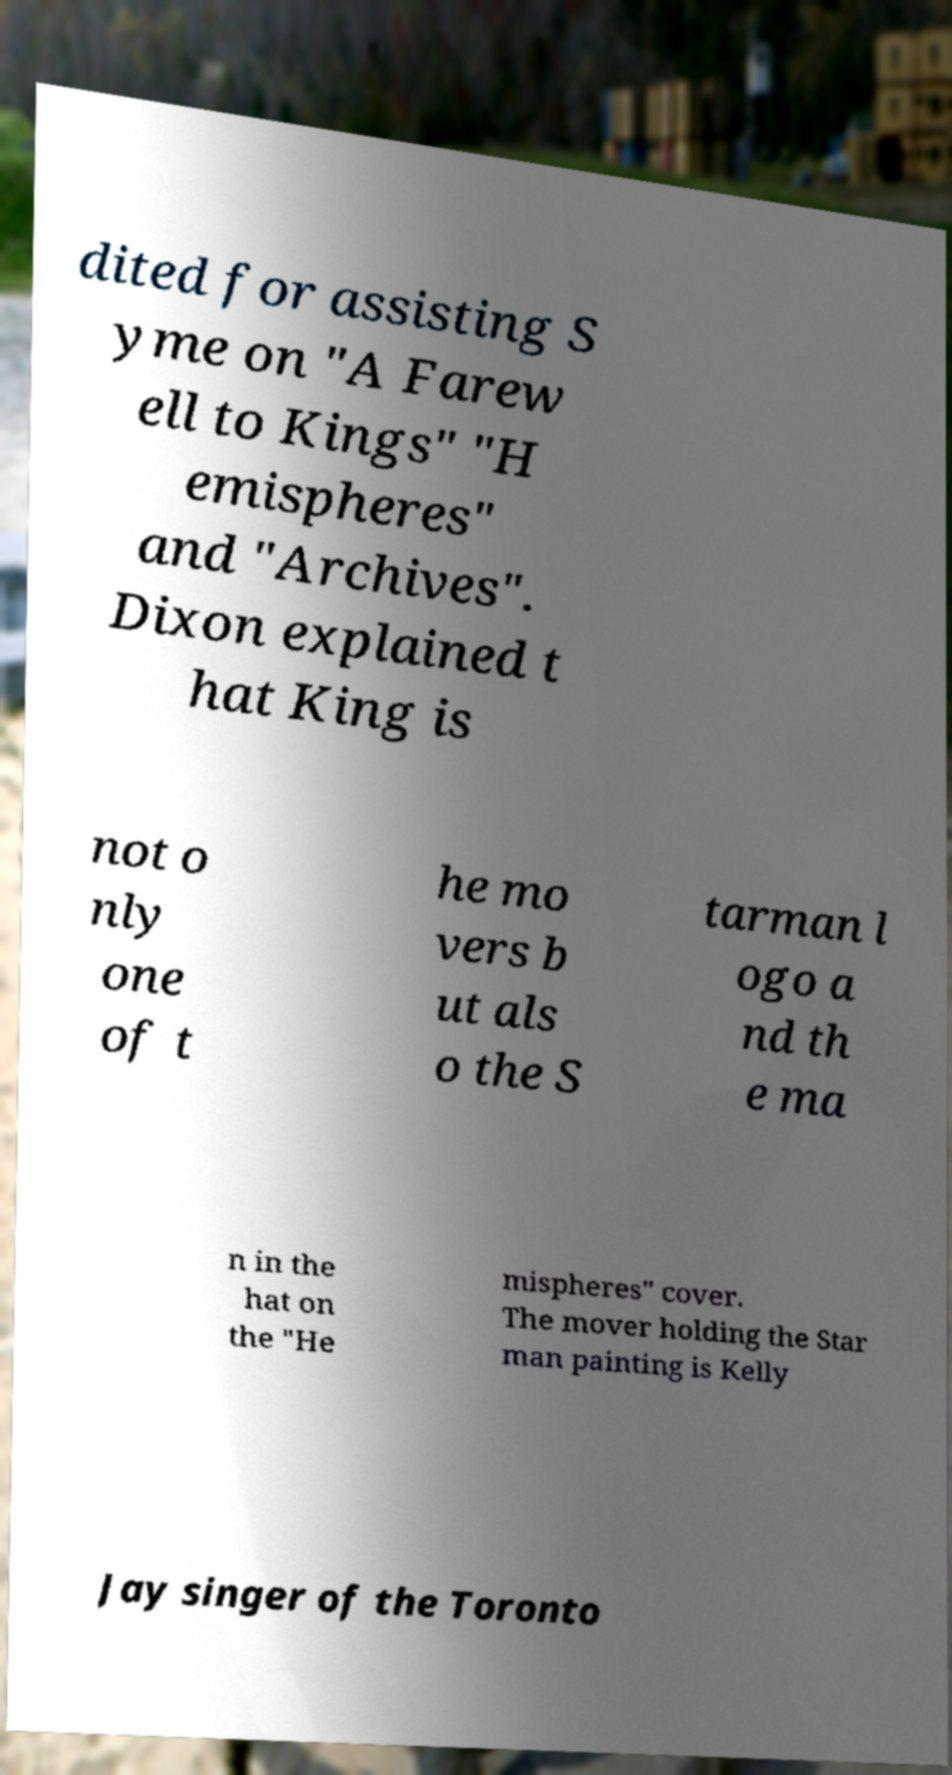Can you accurately transcribe the text from the provided image for me? dited for assisting S yme on "A Farew ell to Kings" "H emispheres" and "Archives". Dixon explained t hat King is not o nly one of t he mo vers b ut als o the S tarman l ogo a nd th e ma n in the hat on the "He mispheres" cover. The mover holding the Star man painting is Kelly Jay singer of the Toronto 